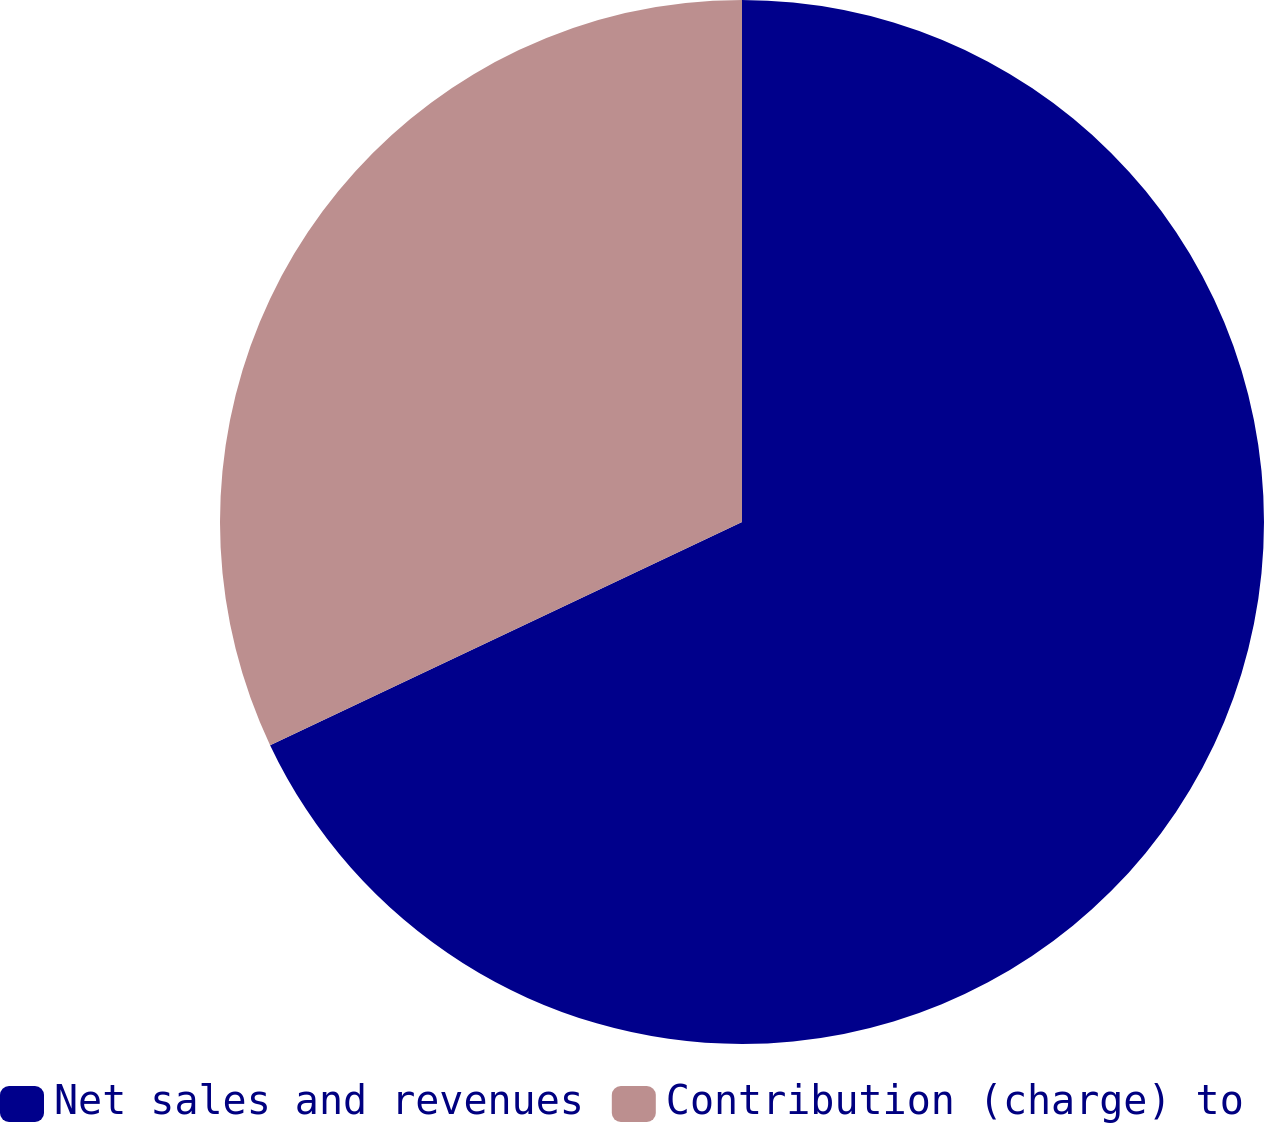<chart> <loc_0><loc_0><loc_500><loc_500><pie_chart><fcel>Net sales and revenues<fcel>Contribution (charge) to<nl><fcel>67.97%<fcel>32.03%<nl></chart> 